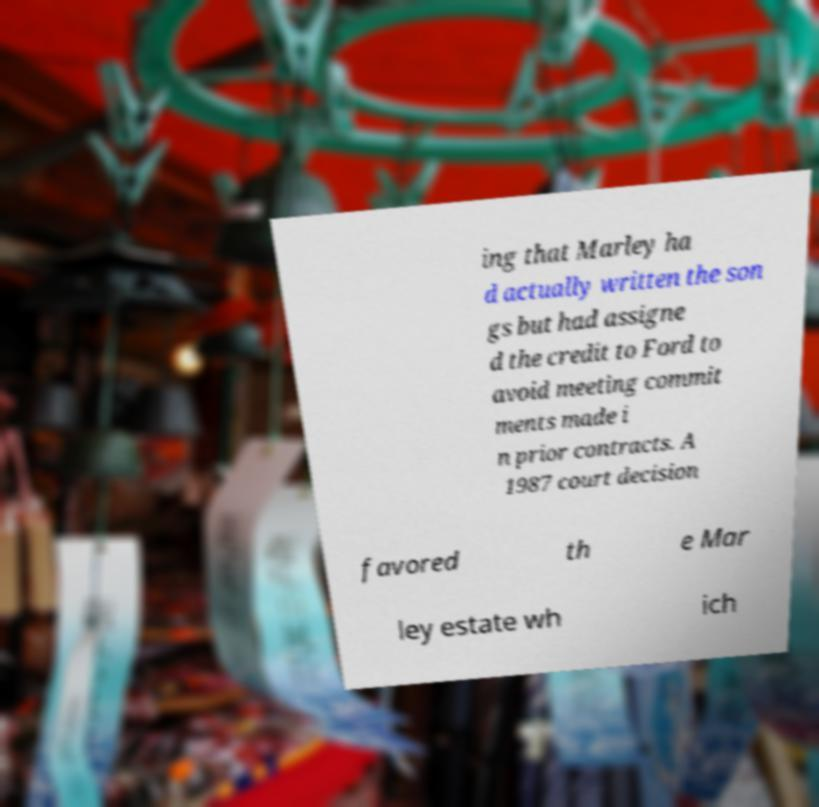I need the written content from this picture converted into text. Can you do that? ing that Marley ha d actually written the son gs but had assigne d the credit to Ford to avoid meeting commit ments made i n prior contracts. A 1987 court decision favored th e Mar ley estate wh ich 